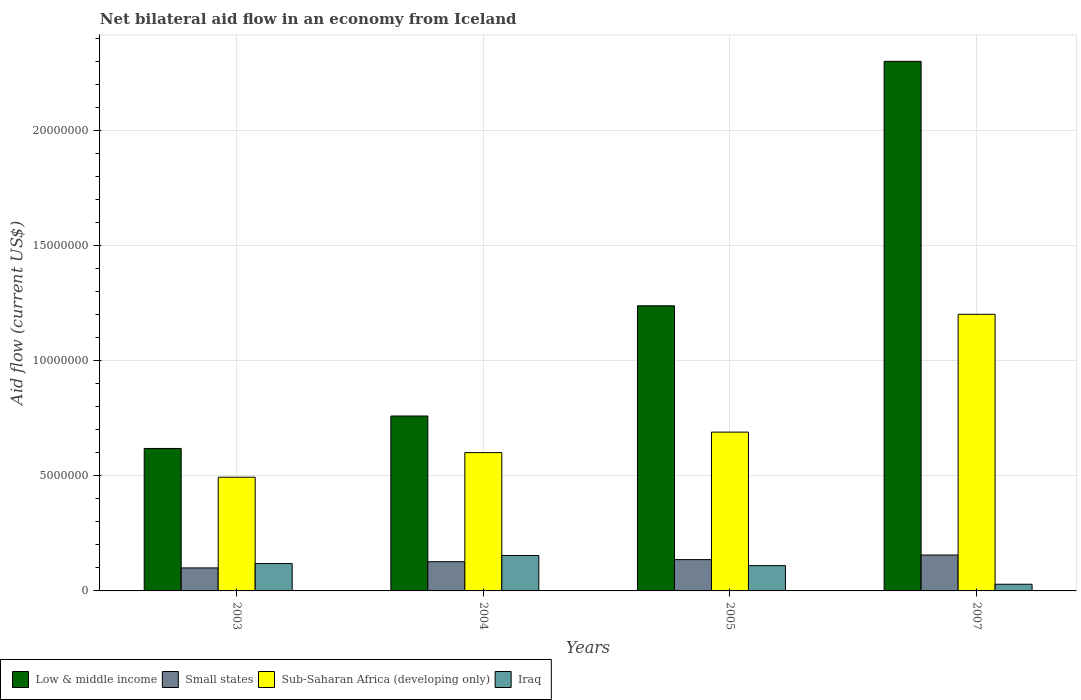How many different coloured bars are there?
Your response must be concise. 4. Are the number of bars per tick equal to the number of legend labels?
Your answer should be compact. Yes. How many bars are there on the 1st tick from the left?
Give a very brief answer. 4. How many bars are there on the 4th tick from the right?
Your response must be concise. 4. In how many cases, is the number of bars for a given year not equal to the number of legend labels?
Your answer should be very brief. 0. What is the net bilateral aid flow in Low & middle income in 2005?
Offer a terse response. 1.24e+07. Across all years, what is the maximum net bilateral aid flow in Low & middle income?
Ensure brevity in your answer.  2.30e+07. Across all years, what is the minimum net bilateral aid flow in Low & middle income?
Your answer should be compact. 6.19e+06. In which year was the net bilateral aid flow in Low & middle income maximum?
Ensure brevity in your answer.  2007. What is the total net bilateral aid flow in Low & middle income in the graph?
Give a very brief answer. 4.92e+07. What is the difference between the net bilateral aid flow in Low & middle income in 2004 and that in 2007?
Provide a succinct answer. -1.54e+07. What is the difference between the net bilateral aid flow in Iraq in 2007 and the net bilateral aid flow in Low & middle income in 2004?
Offer a terse response. -7.31e+06. What is the average net bilateral aid flow in Small states per year?
Ensure brevity in your answer.  1.30e+06. In the year 2004, what is the difference between the net bilateral aid flow in Low & middle income and net bilateral aid flow in Iraq?
Your answer should be compact. 6.06e+06. In how many years, is the net bilateral aid flow in Iraq greater than 15000000 US$?
Offer a very short reply. 0. What is the ratio of the net bilateral aid flow in Iraq in 2003 to that in 2007?
Make the answer very short. 4.1. Is the difference between the net bilateral aid flow in Low & middle income in 2004 and 2005 greater than the difference between the net bilateral aid flow in Iraq in 2004 and 2005?
Provide a succinct answer. No. What is the difference between the highest and the second highest net bilateral aid flow in Iraq?
Your answer should be very brief. 3.50e+05. What is the difference between the highest and the lowest net bilateral aid flow in Sub-Saharan Africa (developing only)?
Give a very brief answer. 7.08e+06. Is the sum of the net bilateral aid flow in Sub-Saharan Africa (developing only) in 2003 and 2007 greater than the maximum net bilateral aid flow in Iraq across all years?
Make the answer very short. Yes. Is it the case that in every year, the sum of the net bilateral aid flow in Small states and net bilateral aid flow in Iraq is greater than the sum of net bilateral aid flow in Sub-Saharan Africa (developing only) and net bilateral aid flow in Low & middle income?
Your answer should be compact. No. What does the 3rd bar from the left in 2004 represents?
Keep it short and to the point. Sub-Saharan Africa (developing only). What does the 1st bar from the right in 2004 represents?
Your answer should be compact. Iraq. Are all the bars in the graph horizontal?
Offer a terse response. No. What is the difference between two consecutive major ticks on the Y-axis?
Give a very brief answer. 5.00e+06. Are the values on the major ticks of Y-axis written in scientific E-notation?
Your answer should be compact. No. Does the graph contain any zero values?
Ensure brevity in your answer.  No. Where does the legend appear in the graph?
Your answer should be compact. Bottom left. How are the legend labels stacked?
Keep it short and to the point. Horizontal. What is the title of the graph?
Make the answer very short. Net bilateral aid flow in an economy from Iceland. What is the label or title of the X-axis?
Your answer should be compact. Years. What is the label or title of the Y-axis?
Your answer should be compact. Aid flow (current US$). What is the Aid flow (current US$) of Low & middle income in 2003?
Ensure brevity in your answer.  6.19e+06. What is the Aid flow (current US$) of Sub-Saharan Africa (developing only) in 2003?
Your answer should be very brief. 4.94e+06. What is the Aid flow (current US$) in Iraq in 2003?
Keep it short and to the point. 1.19e+06. What is the Aid flow (current US$) of Low & middle income in 2004?
Give a very brief answer. 7.60e+06. What is the Aid flow (current US$) in Small states in 2004?
Make the answer very short. 1.27e+06. What is the Aid flow (current US$) in Sub-Saharan Africa (developing only) in 2004?
Give a very brief answer. 6.01e+06. What is the Aid flow (current US$) of Iraq in 2004?
Your response must be concise. 1.54e+06. What is the Aid flow (current US$) in Low & middle income in 2005?
Give a very brief answer. 1.24e+07. What is the Aid flow (current US$) of Small states in 2005?
Provide a succinct answer. 1.36e+06. What is the Aid flow (current US$) in Sub-Saharan Africa (developing only) in 2005?
Provide a succinct answer. 6.90e+06. What is the Aid flow (current US$) of Iraq in 2005?
Offer a very short reply. 1.10e+06. What is the Aid flow (current US$) of Low & middle income in 2007?
Ensure brevity in your answer.  2.30e+07. What is the Aid flow (current US$) of Small states in 2007?
Make the answer very short. 1.56e+06. What is the Aid flow (current US$) of Sub-Saharan Africa (developing only) in 2007?
Offer a very short reply. 1.20e+07. What is the Aid flow (current US$) of Iraq in 2007?
Give a very brief answer. 2.90e+05. Across all years, what is the maximum Aid flow (current US$) of Low & middle income?
Provide a short and direct response. 2.30e+07. Across all years, what is the maximum Aid flow (current US$) of Small states?
Ensure brevity in your answer.  1.56e+06. Across all years, what is the maximum Aid flow (current US$) in Sub-Saharan Africa (developing only)?
Offer a terse response. 1.20e+07. Across all years, what is the maximum Aid flow (current US$) in Iraq?
Offer a very short reply. 1.54e+06. Across all years, what is the minimum Aid flow (current US$) in Low & middle income?
Give a very brief answer. 6.19e+06. Across all years, what is the minimum Aid flow (current US$) of Sub-Saharan Africa (developing only)?
Your answer should be very brief. 4.94e+06. What is the total Aid flow (current US$) in Low & middle income in the graph?
Make the answer very short. 4.92e+07. What is the total Aid flow (current US$) in Small states in the graph?
Your answer should be very brief. 5.19e+06. What is the total Aid flow (current US$) of Sub-Saharan Africa (developing only) in the graph?
Give a very brief answer. 2.99e+07. What is the total Aid flow (current US$) of Iraq in the graph?
Give a very brief answer. 4.12e+06. What is the difference between the Aid flow (current US$) of Low & middle income in 2003 and that in 2004?
Provide a short and direct response. -1.41e+06. What is the difference between the Aid flow (current US$) in Small states in 2003 and that in 2004?
Provide a short and direct response. -2.70e+05. What is the difference between the Aid flow (current US$) in Sub-Saharan Africa (developing only) in 2003 and that in 2004?
Provide a short and direct response. -1.07e+06. What is the difference between the Aid flow (current US$) of Iraq in 2003 and that in 2004?
Offer a terse response. -3.50e+05. What is the difference between the Aid flow (current US$) in Low & middle income in 2003 and that in 2005?
Your response must be concise. -6.20e+06. What is the difference between the Aid flow (current US$) in Small states in 2003 and that in 2005?
Keep it short and to the point. -3.60e+05. What is the difference between the Aid flow (current US$) of Sub-Saharan Africa (developing only) in 2003 and that in 2005?
Ensure brevity in your answer.  -1.96e+06. What is the difference between the Aid flow (current US$) in Iraq in 2003 and that in 2005?
Offer a terse response. 9.00e+04. What is the difference between the Aid flow (current US$) in Low & middle income in 2003 and that in 2007?
Provide a succinct answer. -1.68e+07. What is the difference between the Aid flow (current US$) of Small states in 2003 and that in 2007?
Keep it short and to the point. -5.60e+05. What is the difference between the Aid flow (current US$) of Sub-Saharan Africa (developing only) in 2003 and that in 2007?
Provide a succinct answer. -7.08e+06. What is the difference between the Aid flow (current US$) of Low & middle income in 2004 and that in 2005?
Provide a succinct answer. -4.79e+06. What is the difference between the Aid flow (current US$) in Small states in 2004 and that in 2005?
Provide a short and direct response. -9.00e+04. What is the difference between the Aid flow (current US$) of Sub-Saharan Africa (developing only) in 2004 and that in 2005?
Keep it short and to the point. -8.90e+05. What is the difference between the Aid flow (current US$) of Low & middle income in 2004 and that in 2007?
Provide a succinct answer. -1.54e+07. What is the difference between the Aid flow (current US$) in Small states in 2004 and that in 2007?
Your answer should be compact. -2.90e+05. What is the difference between the Aid flow (current US$) of Sub-Saharan Africa (developing only) in 2004 and that in 2007?
Make the answer very short. -6.01e+06. What is the difference between the Aid flow (current US$) of Iraq in 2004 and that in 2007?
Your answer should be compact. 1.25e+06. What is the difference between the Aid flow (current US$) in Low & middle income in 2005 and that in 2007?
Your answer should be compact. -1.06e+07. What is the difference between the Aid flow (current US$) of Small states in 2005 and that in 2007?
Keep it short and to the point. -2.00e+05. What is the difference between the Aid flow (current US$) in Sub-Saharan Africa (developing only) in 2005 and that in 2007?
Keep it short and to the point. -5.12e+06. What is the difference between the Aid flow (current US$) of Iraq in 2005 and that in 2007?
Offer a very short reply. 8.10e+05. What is the difference between the Aid flow (current US$) in Low & middle income in 2003 and the Aid flow (current US$) in Small states in 2004?
Ensure brevity in your answer.  4.92e+06. What is the difference between the Aid flow (current US$) in Low & middle income in 2003 and the Aid flow (current US$) in Sub-Saharan Africa (developing only) in 2004?
Ensure brevity in your answer.  1.80e+05. What is the difference between the Aid flow (current US$) of Low & middle income in 2003 and the Aid flow (current US$) of Iraq in 2004?
Provide a succinct answer. 4.65e+06. What is the difference between the Aid flow (current US$) in Small states in 2003 and the Aid flow (current US$) in Sub-Saharan Africa (developing only) in 2004?
Your answer should be compact. -5.01e+06. What is the difference between the Aid flow (current US$) in Small states in 2003 and the Aid flow (current US$) in Iraq in 2004?
Give a very brief answer. -5.40e+05. What is the difference between the Aid flow (current US$) of Sub-Saharan Africa (developing only) in 2003 and the Aid flow (current US$) of Iraq in 2004?
Ensure brevity in your answer.  3.40e+06. What is the difference between the Aid flow (current US$) of Low & middle income in 2003 and the Aid flow (current US$) of Small states in 2005?
Keep it short and to the point. 4.83e+06. What is the difference between the Aid flow (current US$) in Low & middle income in 2003 and the Aid flow (current US$) in Sub-Saharan Africa (developing only) in 2005?
Ensure brevity in your answer.  -7.10e+05. What is the difference between the Aid flow (current US$) in Low & middle income in 2003 and the Aid flow (current US$) in Iraq in 2005?
Your answer should be very brief. 5.09e+06. What is the difference between the Aid flow (current US$) in Small states in 2003 and the Aid flow (current US$) in Sub-Saharan Africa (developing only) in 2005?
Provide a short and direct response. -5.90e+06. What is the difference between the Aid flow (current US$) in Small states in 2003 and the Aid flow (current US$) in Iraq in 2005?
Your answer should be compact. -1.00e+05. What is the difference between the Aid flow (current US$) in Sub-Saharan Africa (developing only) in 2003 and the Aid flow (current US$) in Iraq in 2005?
Your answer should be very brief. 3.84e+06. What is the difference between the Aid flow (current US$) in Low & middle income in 2003 and the Aid flow (current US$) in Small states in 2007?
Your answer should be compact. 4.63e+06. What is the difference between the Aid flow (current US$) in Low & middle income in 2003 and the Aid flow (current US$) in Sub-Saharan Africa (developing only) in 2007?
Offer a very short reply. -5.83e+06. What is the difference between the Aid flow (current US$) of Low & middle income in 2003 and the Aid flow (current US$) of Iraq in 2007?
Give a very brief answer. 5.90e+06. What is the difference between the Aid flow (current US$) in Small states in 2003 and the Aid flow (current US$) in Sub-Saharan Africa (developing only) in 2007?
Offer a very short reply. -1.10e+07. What is the difference between the Aid flow (current US$) of Small states in 2003 and the Aid flow (current US$) of Iraq in 2007?
Provide a succinct answer. 7.10e+05. What is the difference between the Aid flow (current US$) in Sub-Saharan Africa (developing only) in 2003 and the Aid flow (current US$) in Iraq in 2007?
Ensure brevity in your answer.  4.65e+06. What is the difference between the Aid flow (current US$) in Low & middle income in 2004 and the Aid flow (current US$) in Small states in 2005?
Offer a very short reply. 6.24e+06. What is the difference between the Aid flow (current US$) in Low & middle income in 2004 and the Aid flow (current US$) in Iraq in 2005?
Give a very brief answer. 6.50e+06. What is the difference between the Aid flow (current US$) in Small states in 2004 and the Aid flow (current US$) in Sub-Saharan Africa (developing only) in 2005?
Your answer should be compact. -5.63e+06. What is the difference between the Aid flow (current US$) in Sub-Saharan Africa (developing only) in 2004 and the Aid flow (current US$) in Iraq in 2005?
Keep it short and to the point. 4.91e+06. What is the difference between the Aid flow (current US$) of Low & middle income in 2004 and the Aid flow (current US$) of Small states in 2007?
Make the answer very short. 6.04e+06. What is the difference between the Aid flow (current US$) of Low & middle income in 2004 and the Aid flow (current US$) of Sub-Saharan Africa (developing only) in 2007?
Your response must be concise. -4.42e+06. What is the difference between the Aid flow (current US$) of Low & middle income in 2004 and the Aid flow (current US$) of Iraq in 2007?
Provide a succinct answer. 7.31e+06. What is the difference between the Aid flow (current US$) of Small states in 2004 and the Aid flow (current US$) of Sub-Saharan Africa (developing only) in 2007?
Offer a very short reply. -1.08e+07. What is the difference between the Aid flow (current US$) in Small states in 2004 and the Aid flow (current US$) in Iraq in 2007?
Your response must be concise. 9.80e+05. What is the difference between the Aid flow (current US$) of Sub-Saharan Africa (developing only) in 2004 and the Aid flow (current US$) of Iraq in 2007?
Keep it short and to the point. 5.72e+06. What is the difference between the Aid flow (current US$) in Low & middle income in 2005 and the Aid flow (current US$) in Small states in 2007?
Provide a succinct answer. 1.08e+07. What is the difference between the Aid flow (current US$) in Low & middle income in 2005 and the Aid flow (current US$) in Iraq in 2007?
Give a very brief answer. 1.21e+07. What is the difference between the Aid flow (current US$) in Small states in 2005 and the Aid flow (current US$) in Sub-Saharan Africa (developing only) in 2007?
Give a very brief answer. -1.07e+07. What is the difference between the Aid flow (current US$) in Small states in 2005 and the Aid flow (current US$) in Iraq in 2007?
Your answer should be compact. 1.07e+06. What is the difference between the Aid flow (current US$) of Sub-Saharan Africa (developing only) in 2005 and the Aid flow (current US$) of Iraq in 2007?
Your response must be concise. 6.61e+06. What is the average Aid flow (current US$) of Low & middle income per year?
Ensure brevity in your answer.  1.23e+07. What is the average Aid flow (current US$) in Small states per year?
Offer a very short reply. 1.30e+06. What is the average Aid flow (current US$) in Sub-Saharan Africa (developing only) per year?
Your response must be concise. 7.47e+06. What is the average Aid flow (current US$) in Iraq per year?
Ensure brevity in your answer.  1.03e+06. In the year 2003, what is the difference between the Aid flow (current US$) in Low & middle income and Aid flow (current US$) in Small states?
Make the answer very short. 5.19e+06. In the year 2003, what is the difference between the Aid flow (current US$) in Low & middle income and Aid flow (current US$) in Sub-Saharan Africa (developing only)?
Keep it short and to the point. 1.25e+06. In the year 2003, what is the difference between the Aid flow (current US$) of Small states and Aid flow (current US$) of Sub-Saharan Africa (developing only)?
Make the answer very short. -3.94e+06. In the year 2003, what is the difference between the Aid flow (current US$) of Small states and Aid flow (current US$) of Iraq?
Make the answer very short. -1.90e+05. In the year 2003, what is the difference between the Aid flow (current US$) in Sub-Saharan Africa (developing only) and Aid flow (current US$) in Iraq?
Keep it short and to the point. 3.75e+06. In the year 2004, what is the difference between the Aid flow (current US$) of Low & middle income and Aid flow (current US$) of Small states?
Offer a very short reply. 6.33e+06. In the year 2004, what is the difference between the Aid flow (current US$) of Low & middle income and Aid flow (current US$) of Sub-Saharan Africa (developing only)?
Keep it short and to the point. 1.59e+06. In the year 2004, what is the difference between the Aid flow (current US$) of Low & middle income and Aid flow (current US$) of Iraq?
Offer a terse response. 6.06e+06. In the year 2004, what is the difference between the Aid flow (current US$) in Small states and Aid flow (current US$) in Sub-Saharan Africa (developing only)?
Give a very brief answer. -4.74e+06. In the year 2004, what is the difference between the Aid flow (current US$) of Sub-Saharan Africa (developing only) and Aid flow (current US$) of Iraq?
Your answer should be compact. 4.47e+06. In the year 2005, what is the difference between the Aid flow (current US$) of Low & middle income and Aid flow (current US$) of Small states?
Provide a short and direct response. 1.10e+07. In the year 2005, what is the difference between the Aid flow (current US$) of Low & middle income and Aid flow (current US$) of Sub-Saharan Africa (developing only)?
Keep it short and to the point. 5.49e+06. In the year 2005, what is the difference between the Aid flow (current US$) of Low & middle income and Aid flow (current US$) of Iraq?
Your response must be concise. 1.13e+07. In the year 2005, what is the difference between the Aid flow (current US$) in Small states and Aid flow (current US$) in Sub-Saharan Africa (developing only)?
Keep it short and to the point. -5.54e+06. In the year 2005, what is the difference between the Aid flow (current US$) of Sub-Saharan Africa (developing only) and Aid flow (current US$) of Iraq?
Provide a succinct answer. 5.80e+06. In the year 2007, what is the difference between the Aid flow (current US$) of Low & middle income and Aid flow (current US$) of Small states?
Give a very brief answer. 2.14e+07. In the year 2007, what is the difference between the Aid flow (current US$) of Low & middle income and Aid flow (current US$) of Sub-Saharan Africa (developing only)?
Your answer should be very brief. 1.10e+07. In the year 2007, what is the difference between the Aid flow (current US$) in Low & middle income and Aid flow (current US$) in Iraq?
Keep it short and to the point. 2.27e+07. In the year 2007, what is the difference between the Aid flow (current US$) in Small states and Aid flow (current US$) in Sub-Saharan Africa (developing only)?
Provide a short and direct response. -1.05e+07. In the year 2007, what is the difference between the Aid flow (current US$) in Small states and Aid flow (current US$) in Iraq?
Provide a succinct answer. 1.27e+06. In the year 2007, what is the difference between the Aid flow (current US$) of Sub-Saharan Africa (developing only) and Aid flow (current US$) of Iraq?
Offer a very short reply. 1.17e+07. What is the ratio of the Aid flow (current US$) in Low & middle income in 2003 to that in 2004?
Keep it short and to the point. 0.81. What is the ratio of the Aid flow (current US$) of Small states in 2003 to that in 2004?
Make the answer very short. 0.79. What is the ratio of the Aid flow (current US$) in Sub-Saharan Africa (developing only) in 2003 to that in 2004?
Your answer should be very brief. 0.82. What is the ratio of the Aid flow (current US$) of Iraq in 2003 to that in 2004?
Give a very brief answer. 0.77. What is the ratio of the Aid flow (current US$) of Low & middle income in 2003 to that in 2005?
Provide a succinct answer. 0.5. What is the ratio of the Aid flow (current US$) in Small states in 2003 to that in 2005?
Your response must be concise. 0.74. What is the ratio of the Aid flow (current US$) of Sub-Saharan Africa (developing only) in 2003 to that in 2005?
Give a very brief answer. 0.72. What is the ratio of the Aid flow (current US$) of Iraq in 2003 to that in 2005?
Give a very brief answer. 1.08. What is the ratio of the Aid flow (current US$) in Low & middle income in 2003 to that in 2007?
Your response must be concise. 0.27. What is the ratio of the Aid flow (current US$) in Small states in 2003 to that in 2007?
Offer a terse response. 0.64. What is the ratio of the Aid flow (current US$) in Sub-Saharan Africa (developing only) in 2003 to that in 2007?
Make the answer very short. 0.41. What is the ratio of the Aid flow (current US$) of Iraq in 2003 to that in 2007?
Make the answer very short. 4.1. What is the ratio of the Aid flow (current US$) of Low & middle income in 2004 to that in 2005?
Give a very brief answer. 0.61. What is the ratio of the Aid flow (current US$) in Small states in 2004 to that in 2005?
Give a very brief answer. 0.93. What is the ratio of the Aid flow (current US$) in Sub-Saharan Africa (developing only) in 2004 to that in 2005?
Provide a short and direct response. 0.87. What is the ratio of the Aid flow (current US$) in Iraq in 2004 to that in 2005?
Keep it short and to the point. 1.4. What is the ratio of the Aid flow (current US$) in Low & middle income in 2004 to that in 2007?
Your response must be concise. 0.33. What is the ratio of the Aid flow (current US$) of Small states in 2004 to that in 2007?
Give a very brief answer. 0.81. What is the ratio of the Aid flow (current US$) of Iraq in 2004 to that in 2007?
Your answer should be compact. 5.31. What is the ratio of the Aid flow (current US$) in Low & middle income in 2005 to that in 2007?
Provide a succinct answer. 0.54. What is the ratio of the Aid flow (current US$) in Small states in 2005 to that in 2007?
Ensure brevity in your answer.  0.87. What is the ratio of the Aid flow (current US$) of Sub-Saharan Africa (developing only) in 2005 to that in 2007?
Your response must be concise. 0.57. What is the ratio of the Aid flow (current US$) of Iraq in 2005 to that in 2007?
Provide a short and direct response. 3.79. What is the difference between the highest and the second highest Aid flow (current US$) of Low & middle income?
Your response must be concise. 1.06e+07. What is the difference between the highest and the second highest Aid flow (current US$) of Small states?
Offer a terse response. 2.00e+05. What is the difference between the highest and the second highest Aid flow (current US$) in Sub-Saharan Africa (developing only)?
Keep it short and to the point. 5.12e+06. What is the difference between the highest and the second highest Aid flow (current US$) of Iraq?
Your response must be concise. 3.50e+05. What is the difference between the highest and the lowest Aid flow (current US$) of Low & middle income?
Your response must be concise. 1.68e+07. What is the difference between the highest and the lowest Aid flow (current US$) of Small states?
Make the answer very short. 5.60e+05. What is the difference between the highest and the lowest Aid flow (current US$) in Sub-Saharan Africa (developing only)?
Your answer should be compact. 7.08e+06. What is the difference between the highest and the lowest Aid flow (current US$) in Iraq?
Offer a very short reply. 1.25e+06. 